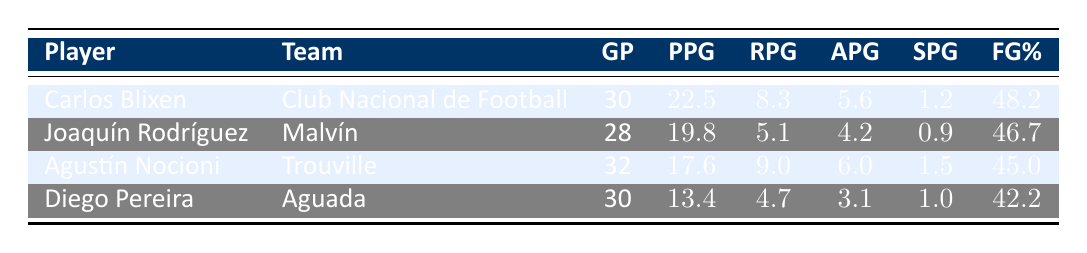What is Carlos Blixen's average points per game? Carlos Blixen's average points per game is directly listed in the table under the "PPG" column. The value provided is 22.5.
Answer: 22.5 How many rebounds does Agustín Nocioni average per game? The average rebounds for Agustín Nocioni can be found under the "RPG" column. The value listed next to his name is 9.0.
Answer: 9.0 Who has the highest field goal percentage among the players listed? By comparing the "FG%" values in the table, Carlos Blixen has the highest field goal percentage at 48.2 compared to the others: Joaquín Rodríguez (46.7), Agustín Nocioni (45.0), and Diego Pereira (42.2).
Answer: Carlos Blixen What is the total number of games played by both Joaquín Rodríguez and Diego Pereira? The number of games played by Joaquín Rodríguez is 28, and by Diego Pereira is 30. Adding these values together gives 28 + 30 = 58.
Answer: 58 Is it true that Agustín Nocioni has more assists per game than Joaquín Rodríguez? To determine this, we compare their assists per game (APG) values: Agustín Nocioni has 6.0 APG and Joaquín Rodríguez has 4.2 APG. Since 6.0 is greater than 4.2, the statement is true.
Answer: Yes What is the average points per game of Diego Pereira and Agustín Nocioni combined? Diego Pereira's points per game is 13.4 and Agustín Nocioni's is 17.6. To find the average, we sum their points: 13.4 + 17.6 = 31.0, then divide by 2: 31.0 / 2 = 15.5.
Answer: 15.5 Which player has the most steals per game? By examining the "SPG" column, we see that Agustín Nocioni has 1.5 steals per game, Carlos Blixen has 1.2, Joaquín Rodríguez has 0.9, and Diego Pereira has 1.0. Agustín Nocioni has the highest value.
Answer: Agustín Nocioni What is the difference in points per game between Carlos Blixen and Diego Pereira? Carlos Blixen's points per game is 22.5, and Diego Pereira's is 13.4. To find the difference, we subtract Diego's points from Carlos's: 22.5 - 13.4 = 9.1.
Answer: 9.1 Did any player average more than 20 points per game? Looking at the "PPG" column, Carlos Blixen has an average of 22.5 points per game, while other players have lower averages: Joaquín Rodríguez (19.8), Agustín Nocioni (17.6), and Diego Pereira (13.4). Therefore, the statement is true.
Answer: Yes 